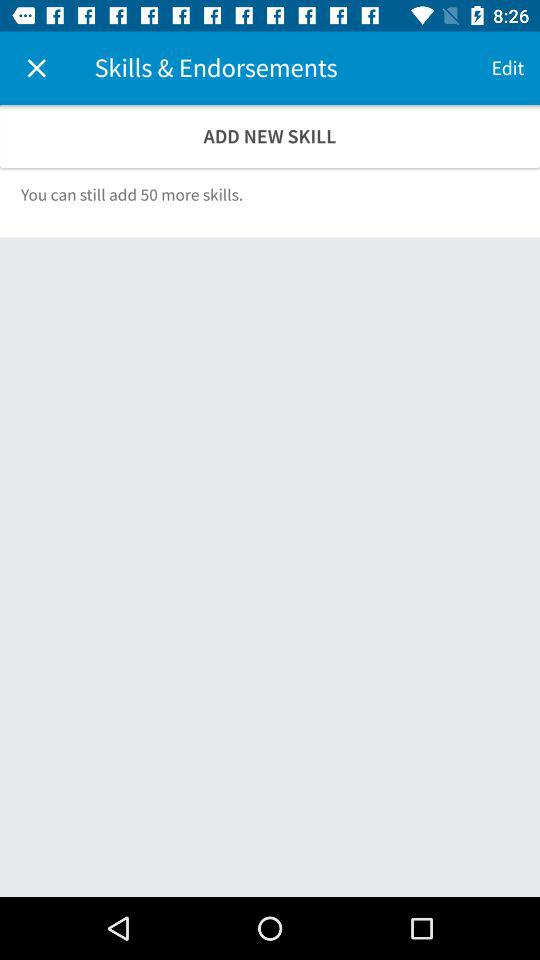How many more skills can be added to the user's profile?
Answer the question using a single word or phrase. 50 